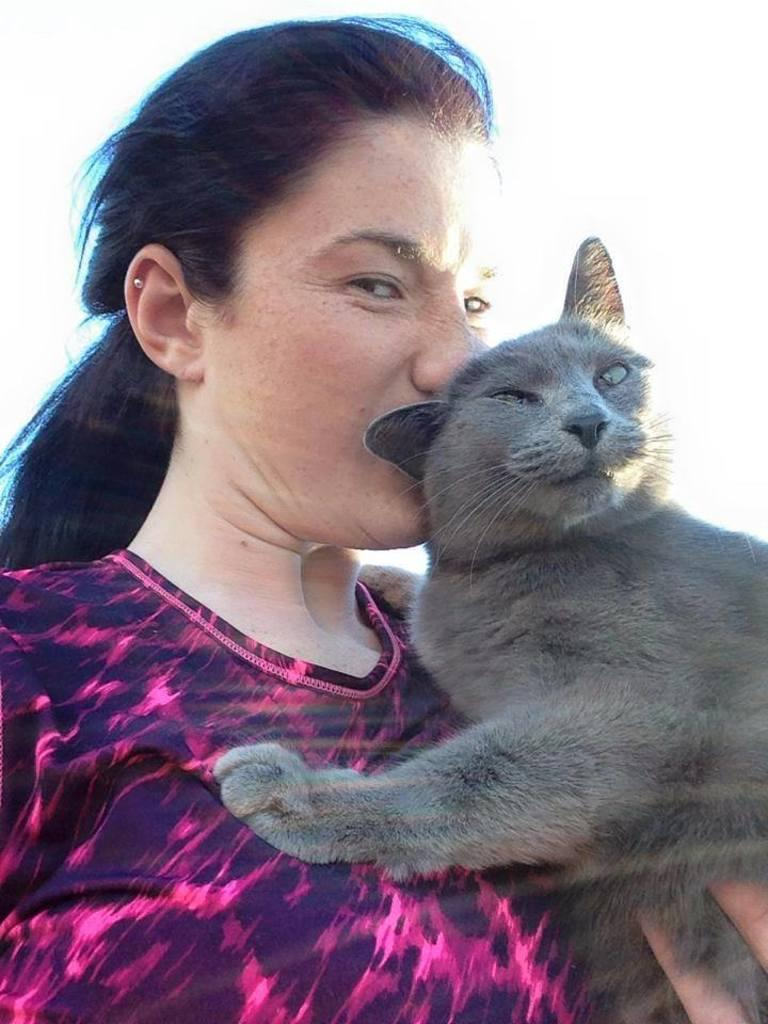Who is present in the image? There is a woman in the image. What is the woman holding in the image? The woman is holding a black color cat. What type of plant can be seen growing near the woman in the image? There is no plant visible in the image. What type of scent is associated with the woman in the image? The image does not provide any information about scents, so it cannot be determined from the image. 